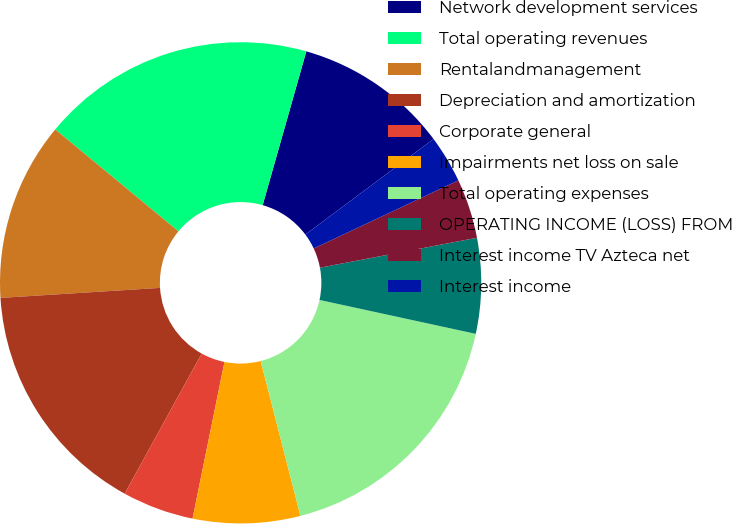Convert chart. <chart><loc_0><loc_0><loc_500><loc_500><pie_chart><fcel>Network development services<fcel>Total operating revenues<fcel>Rentalandmanagement<fcel>Depreciation and amortization<fcel>Corporate general<fcel>Impairments net loss on sale<fcel>Total operating expenses<fcel>OPERATING INCOME (LOSS) FROM<fcel>Interest income TV Azteca net<fcel>Interest income<nl><fcel>10.4%<fcel>18.4%<fcel>12.0%<fcel>16.0%<fcel>4.8%<fcel>7.2%<fcel>17.6%<fcel>6.4%<fcel>4.0%<fcel>3.2%<nl></chart> 